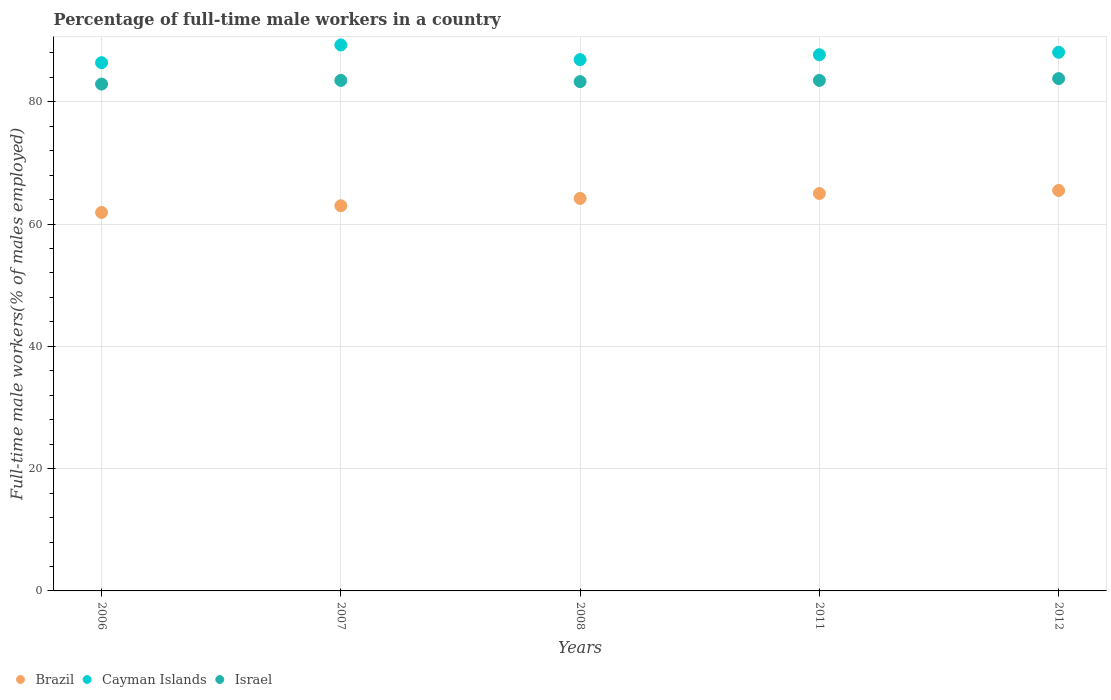What is the percentage of full-time male workers in Brazil in 2008?
Your answer should be compact. 64.2. Across all years, what is the maximum percentage of full-time male workers in Brazil?
Offer a very short reply. 65.5. Across all years, what is the minimum percentage of full-time male workers in Israel?
Ensure brevity in your answer.  82.9. In which year was the percentage of full-time male workers in Brazil maximum?
Provide a succinct answer. 2012. In which year was the percentage of full-time male workers in Israel minimum?
Give a very brief answer. 2006. What is the total percentage of full-time male workers in Brazil in the graph?
Keep it short and to the point. 319.6. What is the difference between the percentage of full-time male workers in Brazil in 2007 and that in 2008?
Offer a terse response. -1.2. What is the difference between the percentage of full-time male workers in Brazil in 2012 and the percentage of full-time male workers in Israel in 2008?
Your answer should be very brief. -17.8. What is the average percentage of full-time male workers in Cayman Islands per year?
Your response must be concise. 87.68. In the year 2007, what is the difference between the percentage of full-time male workers in Brazil and percentage of full-time male workers in Israel?
Your response must be concise. -20.5. In how many years, is the percentage of full-time male workers in Cayman Islands greater than 32 %?
Make the answer very short. 5. What is the ratio of the percentage of full-time male workers in Israel in 2007 to that in 2008?
Make the answer very short. 1. What is the difference between the highest and the second highest percentage of full-time male workers in Israel?
Keep it short and to the point. 0.3. What is the difference between the highest and the lowest percentage of full-time male workers in Israel?
Offer a very short reply. 0.9. Is the sum of the percentage of full-time male workers in Israel in 2007 and 2012 greater than the maximum percentage of full-time male workers in Brazil across all years?
Offer a terse response. Yes. Is it the case that in every year, the sum of the percentage of full-time male workers in Cayman Islands and percentage of full-time male workers in Israel  is greater than the percentage of full-time male workers in Brazil?
Offer a terse response. Yes. Does the graph contain any zero values?
Your answer should be very brief. No. How many legend labels are there?
Offer a terse response. 3. How are the legend labels stacked?
Provide a succinct answer. Horizontal. What is the title of the graph?
Give a very brief answer. Percentage of full-time male workers in a country. Does "Switzerland" appear as one of the legend labels in the graph?
Provide a succinct answer. No. What is the label or title of the Y-axis?
Your answer should be very brief. Full-time male workers(% of males employed). What is the Full-time male workers(% of males employed) in Brazil in 2006?
Provide a short and direct response. 61.9. What is the Full-time male workers(% of males employed) in Cayman Islands in 2006?
Ensure brevity in your answer.  86.4. What is the Full-time male workers(% of males employed) of Israel in 2006?
Provide a succinct answer. 82.9. What is the Full-time male workers(% of males employed) of Brazil in 2007?
Provide a short and direct response. 63. What is the Full-time male workers(% of males employed) of Cayman Islands in 2007?
Ensure brevity in your answer.  89.3. What is the Full-time male workers(% of males employed) of Israel in 2007?
Ensure brevity in your answer.  83.5. What is the Full-time male workers(% of males employed) in Brazil in 2008?
Your answer should be very brief. 64.2. What is the Full-time male workers(% of males employed) in Cayman Islands in 2008?
Ensure brevity in your answer.  86.9. What is the Full-time male workers(% of males employed) in Israel in 2008?
Provide a succinct answer. 83.3. What is the Full-time male workers(% of males employed) of Brazil in 2011?
Make the answer very short. 65. What is the Full-time male workers(% of males employed) in Cayman Islands in 2011?
Provide a short and direct response. 87.7. What is the Full-time male workers(% of males employed) in Israel in 2011?
Provide a short and direct response. 83.5. What is the Full-time male workers(% of males employed) in Brazil in 2012?
Your response must be concise. 65.5. What is the Full-time male workers(% of males employed) in Cayman Islands in 2012?
Your answer should be compact. 88.1. What is the Full-time male workers(% of males employed) of Israel in 2012?
Keep it short and to the point. 83.8. Across all years, what is the maximum Full-time male workers(% of males employed) in Brazil?
Offer a terse response. 65.5. Across all years, what is the maximum Full-time male workers(% of males employed) in Cayman Islands?
Provide a succinct answer. 89.3. Across all years, what is the maximum Full-time male workers(% of males employed) in Israel?
Make the answer very short. 83.8. Across all years, what is the minimum Full-time male workers(% of males employed) of Brazil?
Your answer should be compact. 61.9. Across all years, what is the minimum Full-time male workers(% of males employed) in Cayman Islands?
Provide a succinct answer. 86.4. Across all years, what is the minimum Full-time male workers(% of males employed) of Israel?
Your answer should be compact. 82.9. What is the total Full-time male workers(% of males employed) in Brazil in the graph?
Offer a very short reply. 319.6. What is the total Full-time male workers(% of males employed) in Cayman Islands in the graph?
Your response must be concise. 438.4. What is the total Full-time male workers(% of males employed) of Israel in the graph?
Your answer should be very brief. 417. What is the difference between the Full-time male workers(% of males employed) of Brazil in 2006 and that in 2007?
Provide a short and direct response. -1.1. What is the difference between the Full-time male workers(% of males employed) of Cayman Islands in 2006 and that in 2007?
Provide a short and direct response. -2.9. What is the difference between the Full-time male workers(% of males employed) in Israel in 2006 and that in 2008?
Your answer should be compact. -0.4. What is the difference between the Full-time male workers(% of males employed) of Brazil in 2006 and that in 2011?
Provide a short and direct response. -3.1. What is the difference between the Full-time male workers(% of males employed) of Cayman Islands in 2006 and that in 2011?
Your answer should be compact. -1.3. What is the difference between the Full-time male workers(% of males employed) in Israel in 2006 and that in 2011?
Your response must be concise. -0.6. What is the difference between the Full-time male workers(% of males employed) of Brazil in 2006 and that in 2012?
Your answer should be very brief. -3.6. What is the difference between the Full-time male workers(% of males employed) in Israel in 2007 and that in 2008?
Your answer should be very brief. 0.2. What is the difference between the Full-time male workers(% of males employed) of Cayman Islands in 2007 and that in 2011?
Give a very brief answer. 1.6. What is the difference between the Full-time male workers(% of males employed) in Israel in 2007 and that in 2011?
Give a very brief answer. 0. What is the difference between the Full-time male workers(% of males employed) of Brazil in 2007 and that in 2012?
Ensure brevity in your answer.  -2.5. What is the difference between the Full-time male workers(% of males employed) in Israel in 2007 and that in 2012?
Your response must be concise. -0.3. What is the difference between the Full-time male workers(% of males employed) in Cayman Islands in 2008 and that in 2011?
Your answer should be very brief. -0.8. What is the difference between the Full-time male workers(% of males employed) in Brazil in 2008 and that in 2012?
Offer a very short reply. -1.3. What is the difference between the Full-time male workers(% of males employed) in Israel in 2008 and that in 2012?
Ensure brevity in your answer.  -0.5. What is the difference between the Full-time male workers(% of males employed) of Brazil in 2011 and that in 2012?
Your response must be concise. -0.5. What is the difference between the Full-time male workers(% of males employed) of Israel in 2011 and that in 2012?
Provide a short and direct response. -0.3. What is the difference between the Full-time male workers(% of males employed) of Brazil in 2006 and the Full-time male workers(% of males employed) of Cayman Islands in 2007?
Ensure brevity in your answer.  -27.4. What is the difference between the Full-time male workers(% of males employed) of Brazil in 2006 and the Full-time male workers(% of males employed) of Israel in 2007?
Your answer should be compact. -21.6. What is the difference between the Full-time male workers(% of males employed) in Brazil in 2006 and the Full-time male workers(% of males employed) in Israel in 2008?
Offer a very short reply. -21.4. What is the difference between the Full-time male workers(% of males employed) of Cayman Islands in 2006 and the Full-time male workers(% of males employed) of Israel in 2008?
Make the answer very short. 3.1. What is the difference between the Full-time male workers(% of males employed) of Brazil in 2006 and the Full-time male workers(% of males employed) of Cayman Islands in 2011?
Make the answer very short. -25.8. What is the difference between the Full-time male workers(% of males employed) in Brazil in 2006 and the Full-time male workers(% of males employed) in Israel in 2011?
Keep it short and to the point. -21.6. What is the difference between the Full-time male workers(% of males employed) of Brazil in 2006 and the Full-time male workers(% of males employed) of Cayman Islands in 2012?
Offer a very short reply. -26.2. What is the difference between the Full-time male workers(% of males employed) of Brazil in 2006 and the Full-time male workers(% of males employed) of Israel in 2012?
Your response must be concise. -21.9. What is the difference between the Full-time male workers(% of males employed) of Brazil in 2007 and the Full-time male workers(% of males employed) of Cayman Islands in 2008?
Provide a short and direct response. -23.9. What is the difference between the Full-time male workers(% of males employed) of Brazil in 2007 and the Full-time male workers(% of males employed) of Israel in 2008?
Your response must be concise. -20.3. What is the difference between the Full-time male workers(% of males employed) of Brazil in 2007 and the Full-time male workers(% of males employed) of Cayman Islands in 2011?
Offer a terse response. -24.7. What is the difference between the Full-time male workers(% of males employed) in Brazil in 2007 and the Full-time male workers(% of males employed) in Israel in 2011?
Give a very brief answer. -20.5. What is the difference between the Full-time male workers(% of males employed) of Cayman Islands in 2007 and the Full-time male workers(% of males employed) of Israel in 2011?
Your answer should be very brief. 5.8. What is the difference between the Full-time male workers(% of males employed) of Brazil in 2007 and the Full-time male workers(% of males employed) of Cayman Islands in 2012?
Keep it short and to the point. -25.1. What is the difference between the Full-time male workers(% of males employed) in Brazil in 2007 and the Full-time male workers(% of males employed) in Israel in 2012?
Make the answer very short. -20.8. What is the difference between the Full-time male workers(% of males employed) of Cayman Islands in 2007 and the Full-time male workers(% of males employed) of Israel in 2012?
Make the answer very short. 5.5. What is the difference between the Full-time male workers(% of males employed) of Brazil in 2008 and the Full-time male workers(% of males employed) of Cayman Islands in 2011?
Keep it short and to the point. -23.5. What is the difference between the Full-time male workers(% of males employed) in Brazil in 2008 and the Full-time male workers(% of males employed) in Israel in 2011?
Provide a succinct answer. -19.3. What is the difference between the Full-time male workers(% of males employed) in Brazil in 2008 and the Full-time male workers(% of males employed) in Cayman Islands in 2012?
Your answer should be very brief. -23.9. What is the difference between the Full-time male workers(% of males employed) of Brazil in 2008 and the Full-time male workers(% of males employed) of Israel in 2012?
Keep it short and to the point. -19.6. What is the difference between the Full-time male workers(% of males employed) of Cayman Islands in 2008 and the Full-time male workers(% of males employed) of Israel in 2012?
Give a very brief answer. 3.1. What is the difference between the Full-time male workers(% of males employed) in Brazil in 2011 and the Full-time male workers(% of males employed) in Cayman Islands in 2012?
Ensure brevity in your answer.  -23.1. What is the difference between the Full-time male workers(% of males employed) of Brazil in 2011 and the Full-time male workers(% of males employed) of Israel in 2012?
Provide a succinct answer. -18.8. What is the average Full-time male workers(% of males employed) in Brazil per year?
Your answer should be compact. 63.92. What is the average Full-time male workers(% of males employed) of Cayman Islands per year?
Keep it short and to the point. 87.68. What is the average Full-time male workers(% of males employed) in Israel per year?
Give a very brief answer. 83.4. In the year 2006, what is the difference between the Full-time male workers(% of males employed) in Brazil and Full-time male workers(% of males employed) in Cayman Islands?
Your response must be concise. -24.5. In the year 2007, what is the difference between the Full-time male workers(% of males employed) of Brazil and Full-time male workers(% of males employed) of Cayman Islands?
Ensure brevity in your answer.  -26.3. In the year 2007, what is the difference between the Full-time male workers(% of males employed) of Brazil and Full-time male workers(% of males employed) of Israel?
Offer a terse response. -20.5. In the year 2007, what is the difference between the Full-time male workers(% of males employed) of Cayman Islands and Full-time male workers(% of males employed) of Israel?
Provide a short and direct response. 5.8. In the year 2008, what is the difference between the Full-time male workers(% of males employed) of Brazil and Full-time male workers(% of males employed) of Cayman Islands?
Your answer should be very brief. -22.7. In the year 2008, what is the difference between the Full-time male workers(% of males employed) of Brazil and Full-time male workers(% of males employed) of Israel?
Provide a succinct answer. -19.1. In the year 2008, what is the difference between the Full-time male workers(% of males employed) in Cayman Islands and Full-time male workers(% of males employed) in Israel?
Your answer should be very brief. 3.6. In the year 2011, what is the difference between the Full-time male workers(% of males employed) of Brazil and Full-time male workers(% of males employed) of Cayman Islands?
Provide a succinct answer. -22.7. In the year 2011, what is the difference between the Full-time male workers(% of males employed) of Brazil and Full-time male workers(% of males employed) of Israel?
Your answer should be very brief. -18.5. In the year 2012, what is the difference between the Full-time male workers(% of males employed) in Brazil and Full-time male workers(% of males employed) in Cayman Islands?
Your answer should be very brief. -22.6. In the year 2012, what is the difference between the Full-time male workers(% of males employed) in Brazil and Full-time male workers(% of males employed) in Israel?
Your answer should be compact. -18.3. What is the ratio of the Full-time male workers(% of males employed) of Brazil in 2006 to that in 2007?
Offer a terse response. 0.98. What is the ratio of the Full-time male workers(% of males employed) in Cayman Islands in 2006 to that in 2007?
Ensure brevity in your answer.  0.97. What is the ratio of the Full-time male workers(% of males employed) in Brazil in 2006 to that in 2008?
Your response must be concise. 0.96. What is the ratio of the Full-time male workers(% of males employed) in Cayman Islands in 2006 to that in 2008?
Offer a very short reply. 0.99. What is the ratio of the Full-time male workers(% of males employed) of Israel in 2006 to that in 2008?
Offer a terse response. 1. What is the ratio of the Full-time male workers(% of males employed) in Brazil in 2006 to that in 2011?
Your response must be concise. 0.95. What is the ratio of the Full-time male workers(% of males employed) of Cayman Islands in 2006 to that in 2011?
Provide a succinct answer. 0.99. What is the ratio of the Full-time male workers(% of males employed) of Israel in 2006 to that in 2011?
Provide a succinct answer. 0.99. What is the ratio of the Full-time male workers(% of males employed) in Brazil in 2006 to that in 2012?
Offer a terse response. 0.94. What is the ratio of the Full-time male workers(% of males employed) in Cayman Islands in 2006 to that in 2012?
Give a very brief answer. 0.98. What is the ratio of the Full-time male workers(% of males employed) of Israel in 2006 to that in 2012?
Ensure brevity in your answer.  0.99. What is the ratio of the Full-time male workers(% of males employed) in Brazil in 2007 to that in 2008?
Offer a terse response. 0.98. What is the ratio of the Full-time male workers(% of males employed) of Cayman Islands in 2007 to that in 2008?
Offer a terse response. 1.03. What is the ratio of the Full-time male workers(% of males employed) in Israel in 2007 to that in 2008?
Offer a terse response. 1. What is the ratio of the Full-time male workers(% of males employed) of Brazil in 2007 to that in 2011?
Make the answer very short. 0.97. What is the ratio of the Full-time male workers(% of males employed) of Cayman Islands in 2007 to that in 2011?
Offer a very short reply. 1.02. What is the ratio of the Full-time male workers(% of males employed) of Israel in 2007 to that in 2011?
Provide a short and direct response. 1. What is the ratio of the Full-time male workers(% of males employed) of Brazil in 2007 to that in 2012?
Your answer should be compact. 0.96. What is the ratio of the Full-time male workers(% of males employed) in Cayman Islands in 2007 to that in 2012?
Offer a terse response. 1.01. What is the ratio of the Full-time male workers(% of males employed) in Cayman Islands in 2008 to that in 2011?
Ensure brevity in your answer.  0.99. What is the ratio of the Full-time male workers(% of males employed) in Israel in 2008 to that in 2011?
Keep it short and to the point. 1. What is the ratio of the Full-time male workers(% of males employed) of Brazil in 2008 to that in 2012?
Provide a succinct answer. 0.98. What is the ratio of the Full-time male workers(% of males employed) of Cayman Islands in 2008 to that in 2012?
Offer a terse response. 0.99. What is the ratio of the Full-time male workers(% of males employed) of Brazil in 2011 to that in 2012?
Make the answer very short. 0.99. What is the difference between the highest and the second highest Full-time male workers(% of males employed) of Brazil?
Ensure brevity in your answer.  0.5. What is the difference between the highest and the second highest Full-time male workers(% of males employed) in Cayman Islands?
Give a very brief answer. 1.2. 